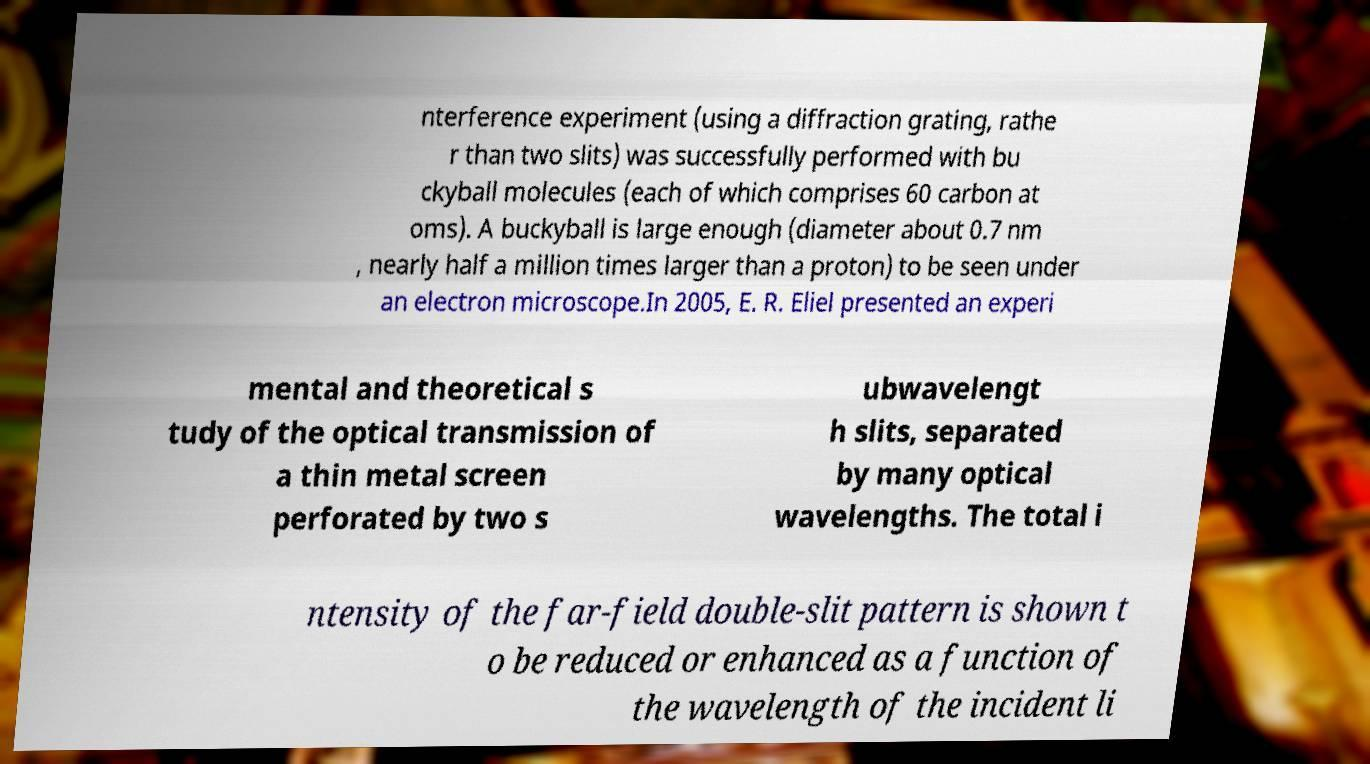Please read and relay the text visible in this image. What does it say? nterference experiment (using a diffraction grating, rathe r than two slits) was successfully performed with bu ckyball molecules (each of which comprises 60 carbon at oms). A buckyball is large enough (diameter about 0.7 nm , nearly half a million times larger than a proton) to be seen under an electron microscope.In 2005, E. R. Eliel presented an experi mental and theoretical s tudy of the optical transmission of a thin metal screen perforated by two s ubwavelengt h slits, separated by many optical wavelengths. The total i ntensity of the far-field double-slit pattern is shown t o be reduced or enhanced as a function of the wavelength of the incident li 